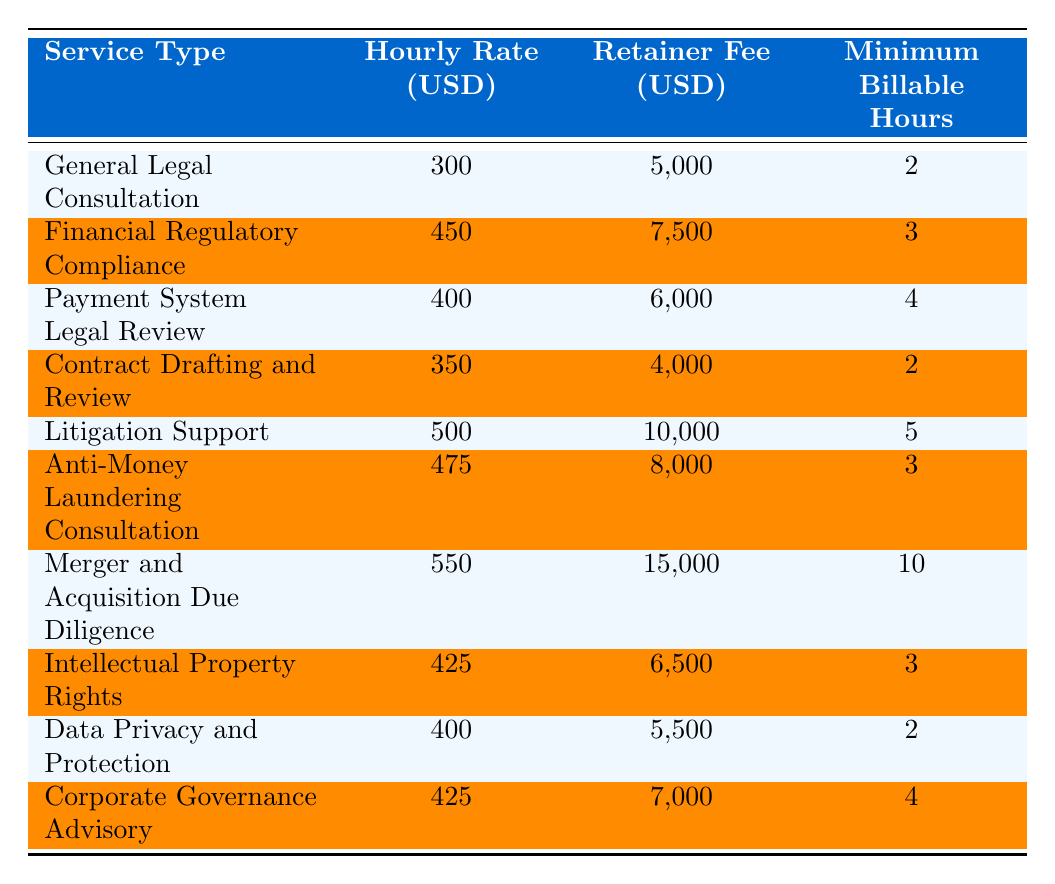What is the hourly rate for Litigation Support? The table shows that the hourly rate for Litigation Support is listed directly in the corresponding row under the "Hourly Rate (USD)" column.
Answer: 500 Which service type has the lowest retainer fee? In the table, I compare the "Retainer Fee (USD)" values for all the service types. The lowest value is 4,000, which corresponds to "Contract Drafting and Review."
Answer: Contract Drafting and Review What is the total of the hourly rates for all services? To find the total, I sum all the hourly rates listed in the "Hourly Rate (USD)" column: (300 + 450 + 400 + 350 + 500 + 475 + 550 + 425 + 400 + 425) = 4275.
Answer: 4275 Does the Anti-Money Laundering Consultation have a higher hourly rate than the General Legal Consultation? I compare the hourly rates for both services: Anti-Money Laundering Consultation has an hourly rate of 475 and General Legal Consultation has 300. Since 475 > 300, the statement is true.
Answer: Yes What is the average retainer fee across all services? I first sum all the retainer fees: (5000 + 7500 + 6000 + 4000 + 10000 + 8000 + 15000 + 6500 + 5500 + 7000) = 70000. Then, I divide this total by the number of services, which is 10: 70000/10 = 7000.
Answer: 7000 Which service type requires the most minimum billable hours? I look at the "Minimum Billable Hours" column to find the maximum value. The maximum is 10, which corresponds to "Merger and Acquisition Due Diligence."
Answer: Merger and Acquisition Due Diligence Is the hourly rate for Payment System Legal Review higher than that for Corporate Governance Advisory? The hourly rate for Payment System Legal Review is listed as 400, while Corporate Governance Advisory has 425. Comparing these, 400 < 425 means the hourly rate for Payment System Legal Review is not higher.
Answer: No What is the difference in retainer fees between Merger and Acquisition Due Diligence and Financial Regulatory Compliance? I subtract the retainer fee for Financial Regulatory Compliance (7500) from that of Merger and Acquisition Due Diligence (15000): 15000 - 7500 = 7500.
Answer: 7500 